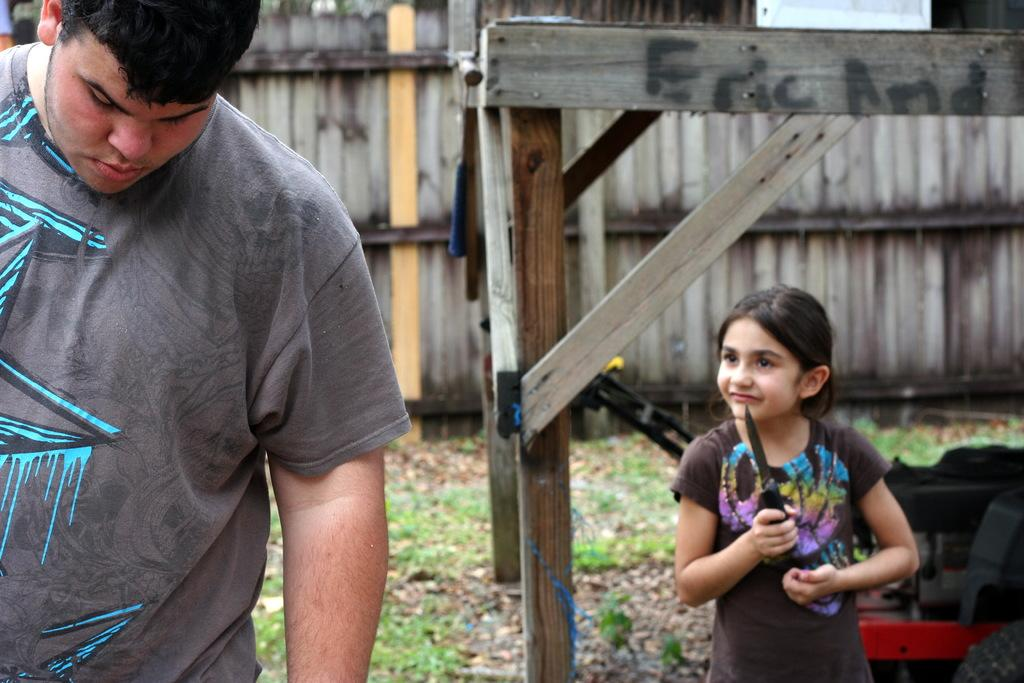What is the main subject of the image? The main subject of the image is a kid. What is the kid holding in the image? The kid is holding a knife. Are there any other people in the image besides the kid? Yes, there is another person in the image. What can be seen on the floor in the image? There is wooden fencing on the floor in the image. What type of fish does the kid have as a hobby in the image? There is no mention of fish or any hobbies related to fish in the image. 